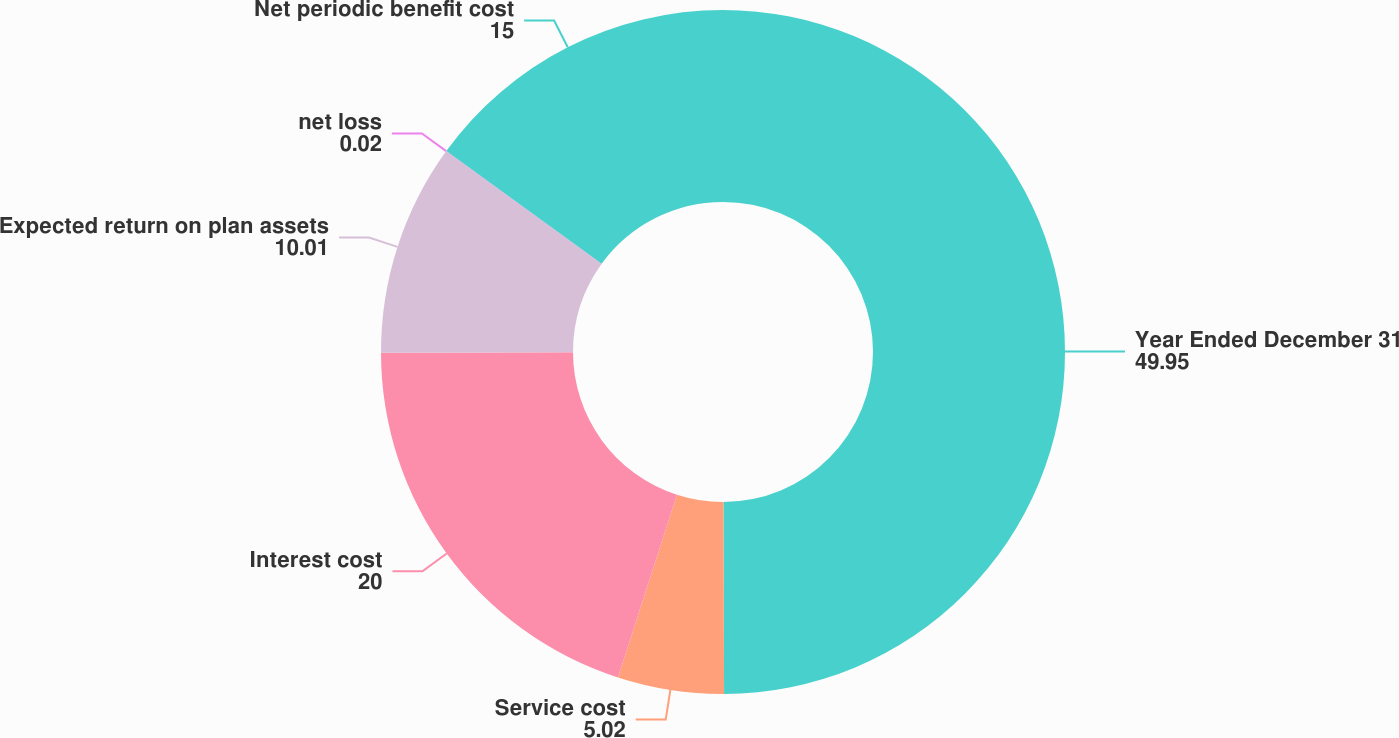<chart> <loc_0><loc_0><loc_500><loc_500><pie_chart><fcel>Year Ended December 31<fcel>Service cost<fcel>Interest cost<fcel>Expected return on plan assets<fcel>net loss<fcel>Net periodic benefit cost<nl><fcel>49.95%<fcel>5.02%<fcel>20.0%<fcel>10.01%<fcel>0.02%<fcel>15.0%<nl></chart> 